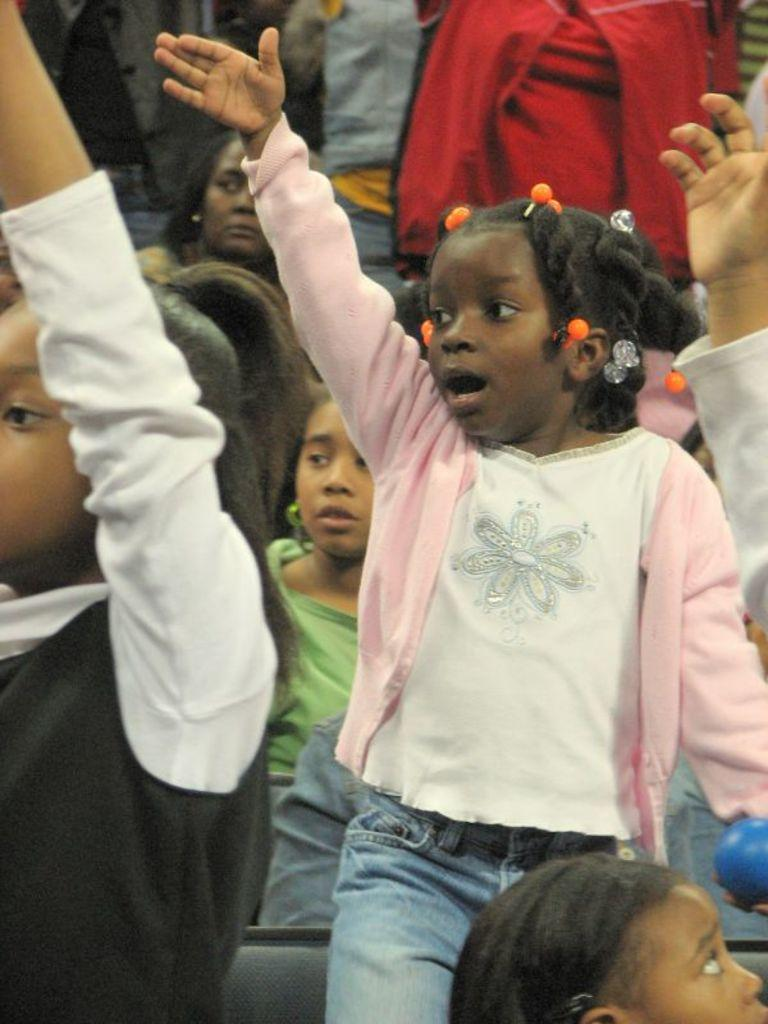Who or what is present in the image? There are kids in the image. What are the kids doing in the image? The kids are raising their hands. Where is the throne located in the image? There is no throne present in the image. How many kisses can be seen on the kids' faces in the image? There are no kisses visible on the kids' faces in the image. 